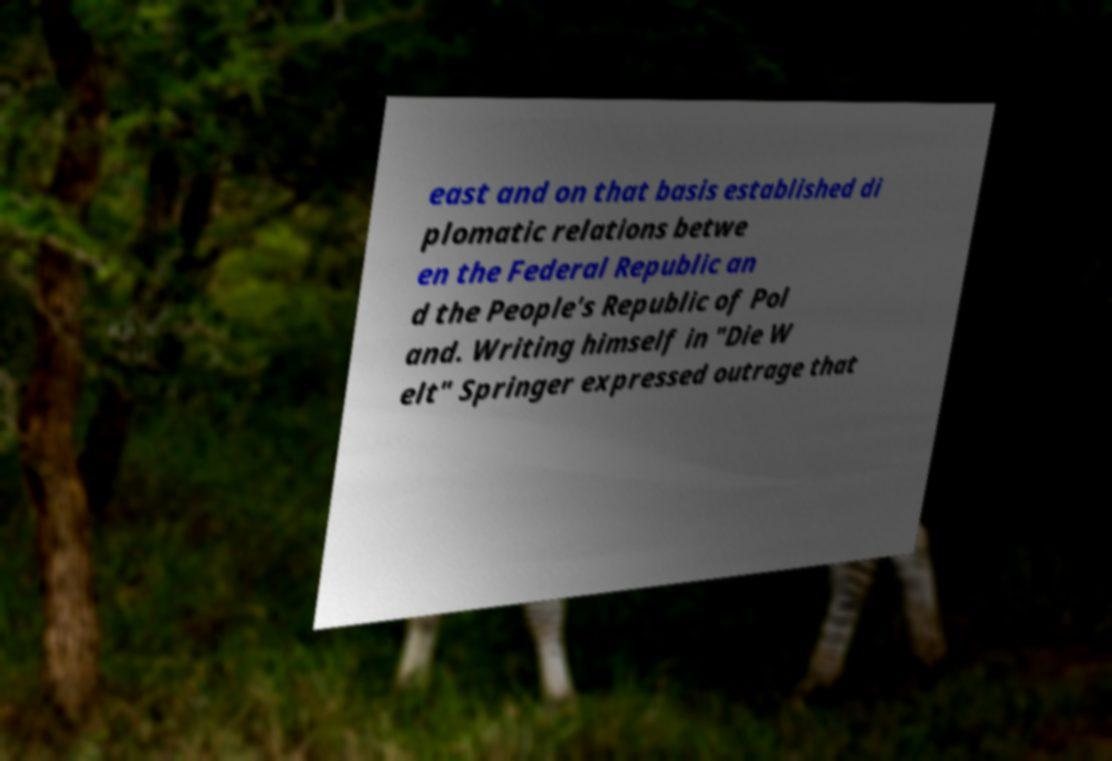Could you extract and type out the text from this image? east and on that basis established di plomatic relations betwe en the Federal Republic an d the People's Republic of Pol and. Writing himself in "Die W elt" Springer expressed outrage that 